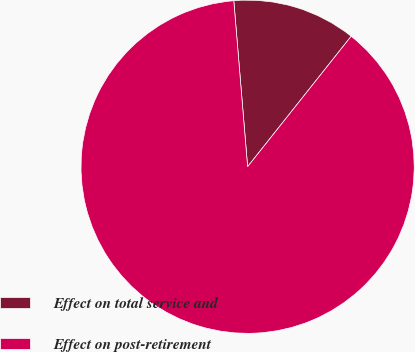Convert chart to OTSL. <chart><loc_0><loc_0><loc_500><loc_500><pie_chart><fcel>Effect on total service and<fcel>Effect on post-retirement<nl><fcel>12.0%<fcel>88.0%<nl></chart> 